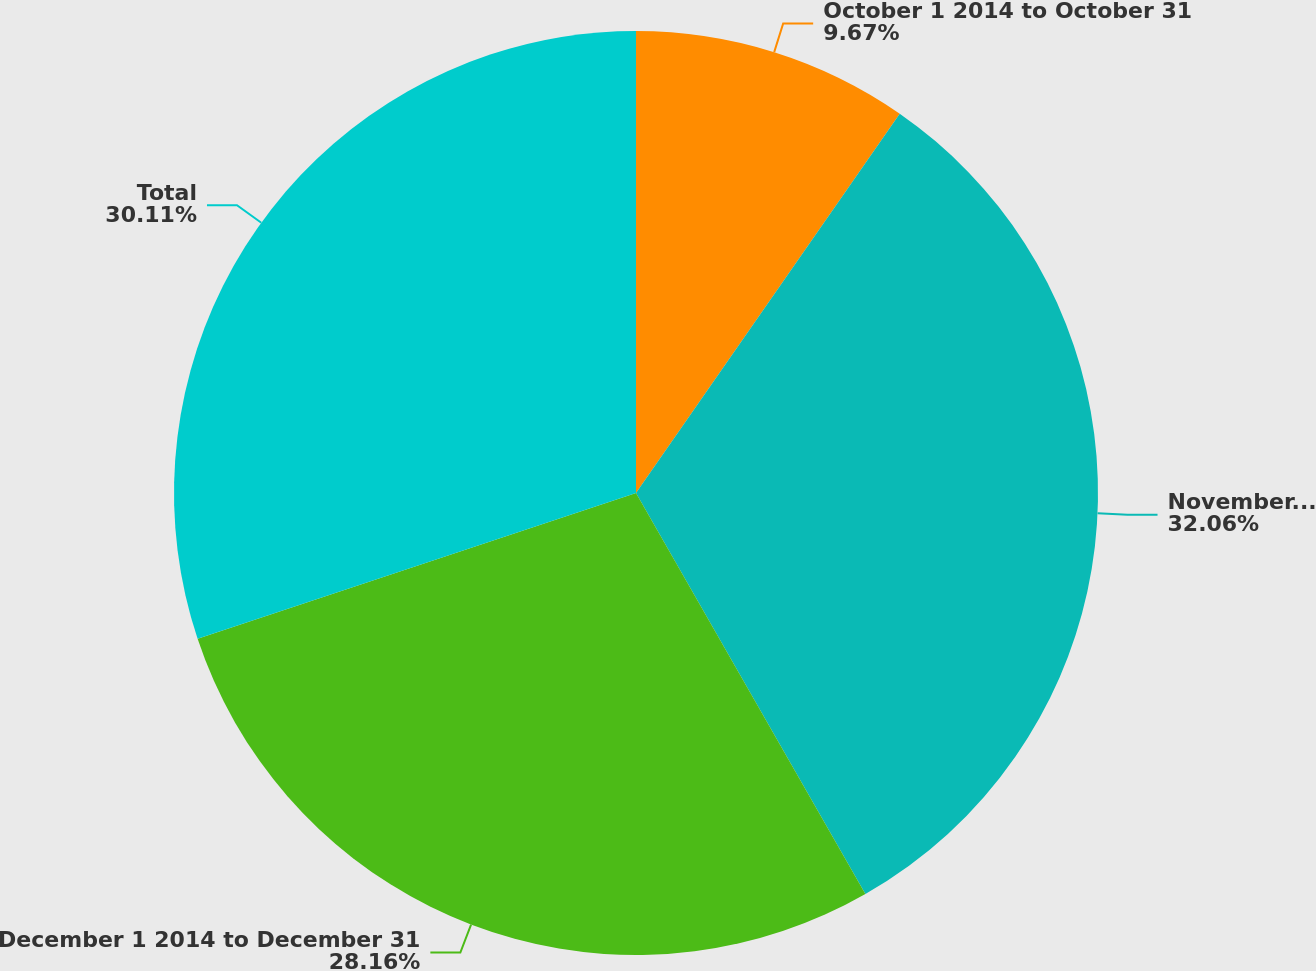Convert chart to OTSL. <chart><loc_0><loc_0><loc_500><loc_500><pie_chart><fcel>October 1 2014 to October 31<fcel>November 1 2014 to November 30<fcel>December 1 2014 to December 31<fcel>Total<nl><fcel>9.67%<fcel>32.06%<fcel>28.16%<fcel>30.11%<nl></chart> 